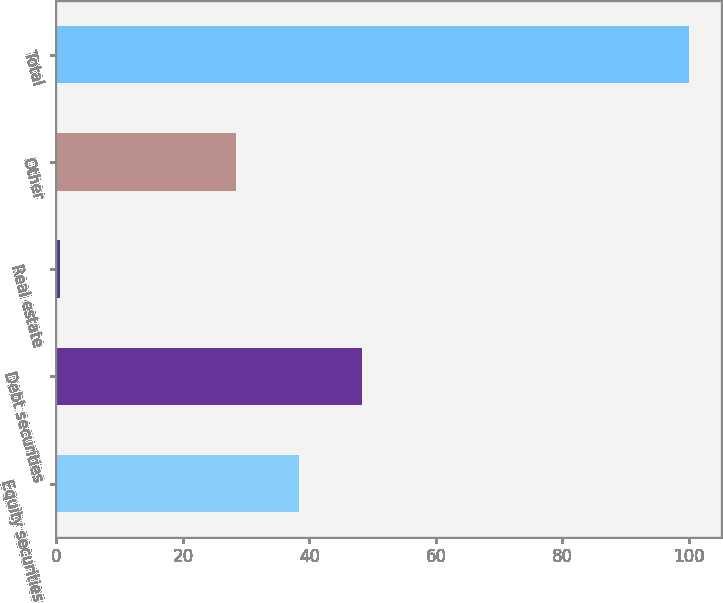<chart> <loc_0><loc_0><loc_500><loc_500><bar_chart><fcel>Equity securities<fcel>Debt securities<fcel>Real estate<fcel>Other<fcel>Total<nl><fcel>38.35<fcel>48.3<fcel>0.5<fcel>28.4<fcel>100<nl></chart> 